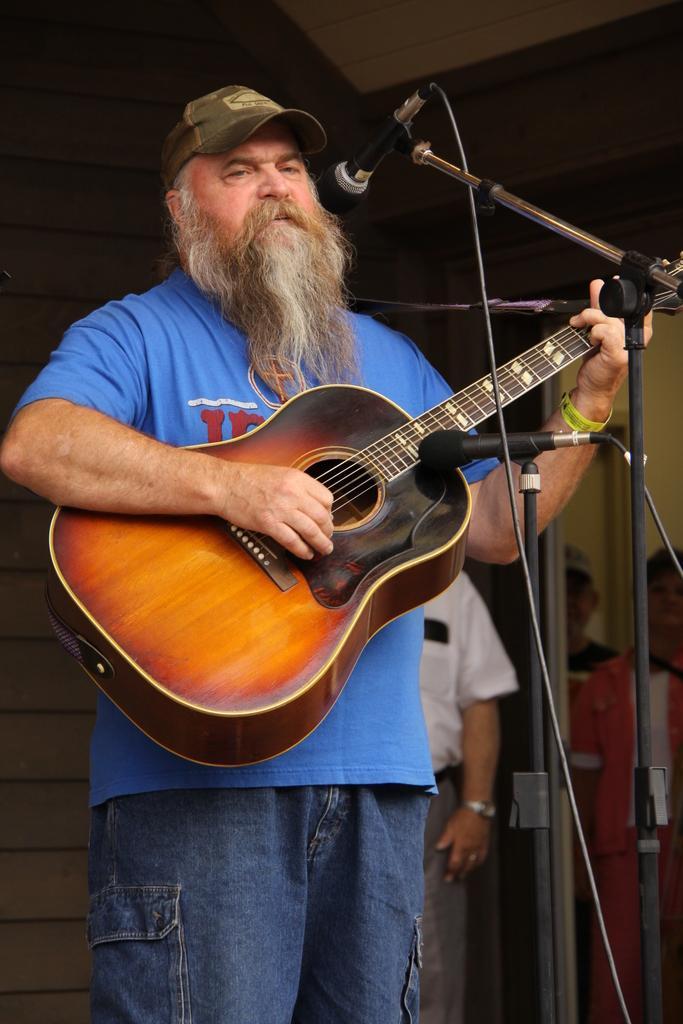Could you give a brief overview of what you see in this image? In this image I see a man who is standing in front of the mics and he is holding a guitar and he is wearing a cap. In the background I see few people. 